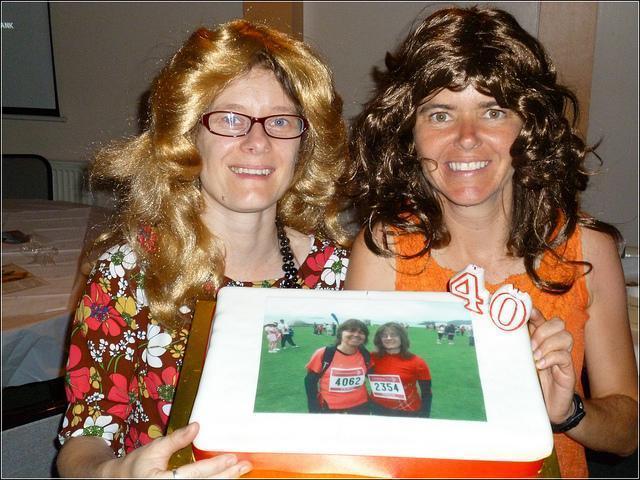Do identical twins have 100% the same DNA?
From the following four choices, select the correct answer to address the question.
Options: Somewhat, true, false, maybe. True. 